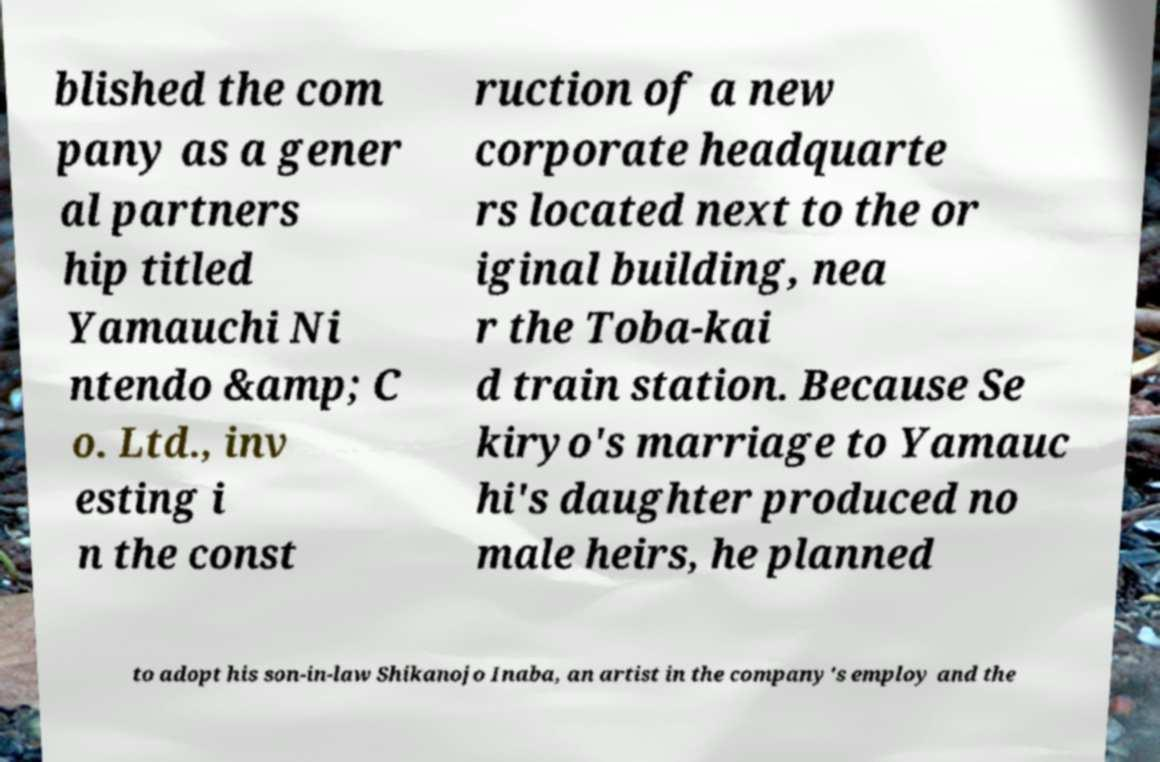Please read and relay the text visible in this image. What does it say? blished the com pany as a gener al partners hip titled Yamauchi Ni ntendo &amp; C o. Ltd., inv esting i n the const ruction of a new corporate headquarte rs located next to the or iginal building, nea r the Toba-kai d train station. Because Se kiryo's marriage to Yamauc hi's daughter produced no male heirs, he planned to adopt his son-in-law Shikanojo Inaba, an artist in the company's employ and the 